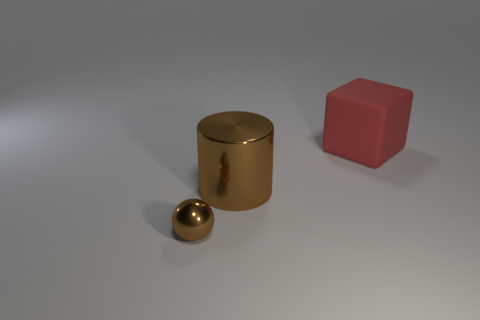Are there any other things that have the same material as the cube?
Your answer should be very brief. No. There is a thing that is both on the left side of the big rubber object and on the right side of the metallic sphere; what is its material?
Provide a short and direct response. Metal. The tiny brown object that is the same material as the large brown cylinder is what shape?
Offer a terse response. Sphere. Are there any other things that have the same color as the big shiny thing?
Offer a terse response. Yes. Is the number of large brown metallic objects behind the small brown shiny sphere greater than the number of small cyan cylinders?
Provide a short and direct response. Yes. What material is the large brown cylinder?
Offer a very short reply. Metal. What number of red matte objects have the same size as the brown shiny cylinder?
Your answer should be compact. 1. Are there the same number of big brown metal objects that are left of the large metallic cylinder and big shiny cylinders that are behind the brown ball?
Your response must be concise. No. Does the large brown cylinder have the same material as the tiny thing?
Give a very brief answer. Yes. Are there any big red rubber things that are behind the object to the right of the brown shiny cylinder?
Your answer should be compact. No. 